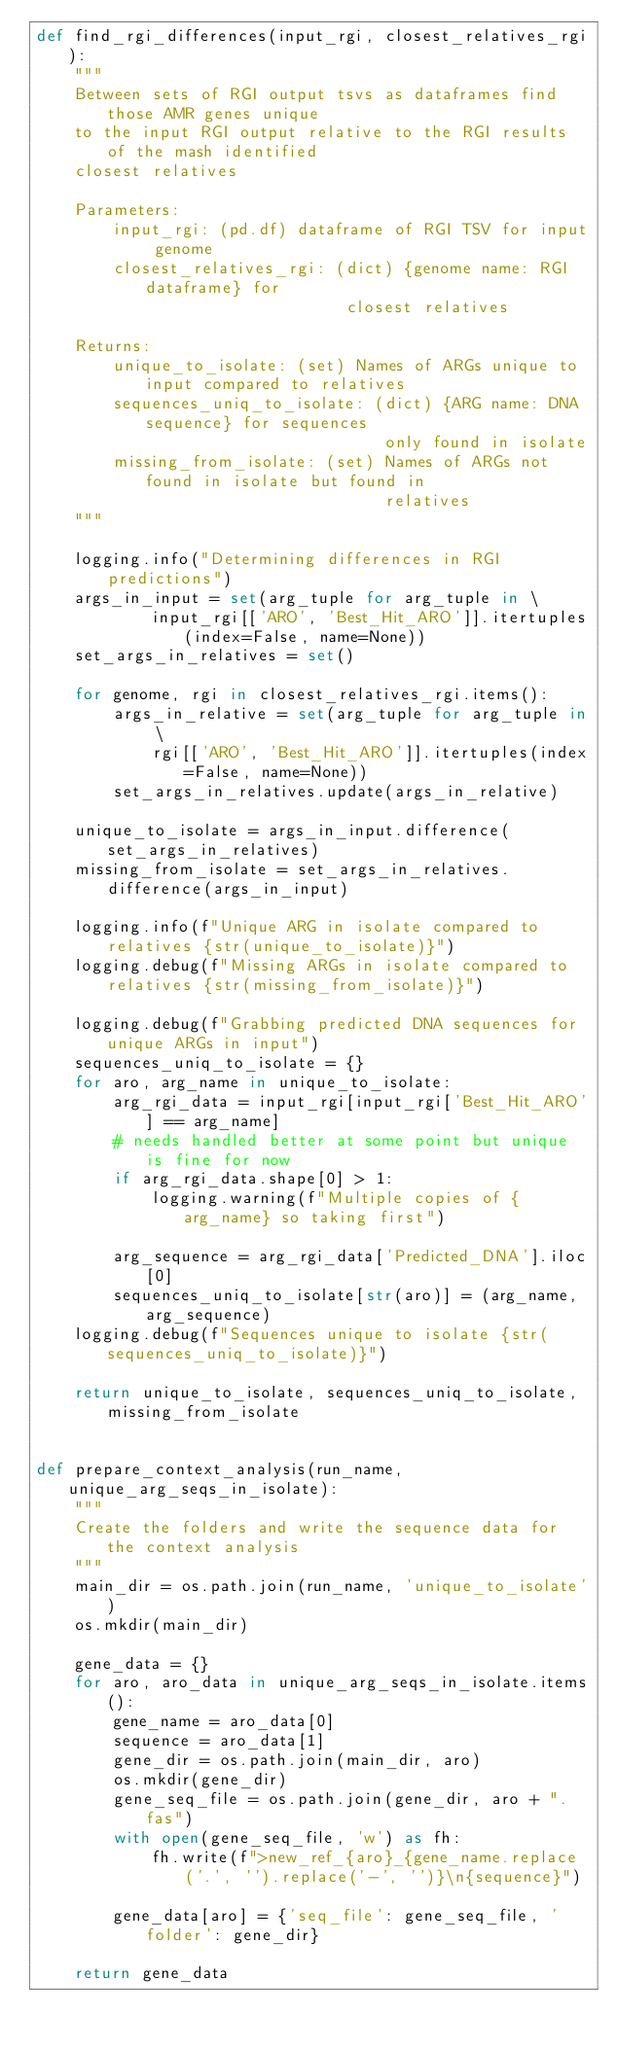Convert code to text. <code><loc_0><loc_0><loc_500><loc_500><_Python_>def find_rgi_differences(input_rgi, closest_relatives_rgi):
    """
    Between sets of RGI output tsvs as dataframes find those AMR genes unique
    to the input RGI output relative to the RGI results of the mash identified
    closest relatives

    Parameters:
        input_rgi: (pd.df) dataframe of RGI TSV for input genome
        closest_relatives_rgi: (dict) {genome name: RGI dataframe} for
                                closest relatives

    Returns:
        unique_to_isolate: (set) Names of ARGs unique to input compared to relatives
        sequences_uniq_to_isolate: (dict) {ARG name: DNA sequence} for sequences
                                    only found in isolate
        missing_from_isolate: (set) Names of ARGs not found in isolate but found in
                                    relatives
    """

    logging.info("Determining differences in RGI predictions")
    args_in_input = set(arg_tuple for arg_tuple in \
            input_rgi[['ARO', 'Best_Hit_ARO']].itertuples(index=False, name=None))
    set_args_in_relatives = set()

    for genome, rgi in closest_relatives_rgi.items():
        args_in_relative = set(arg_tuple for arg_tuple in \
            rgi[['ARO', 'Best_Hit_ARO']].itertuples(index=False, name=None))
        set_args_in_relatives.update(args_in_relative)

    unique_to_isolate = args_in_input.difference(set_args_in_relatives)
    missing_from_isolate = set_args_in_relatives.difference(args_in_input)

    logging.info(f"Unique ARG in isolate compared to relatives {str(unique_to_isolate)}")
    logging.debug(f"Missing ARGs in isolate compared to relatives {str(missing_from_isolate)}")

    logging.debug(f"Grabbing predicted DNA sequences for unique ARGs in input")
    sequences_uniq_to_isolate = {}
    for aro, arg_name in unique_to_isolate:
        arg_rgi_data = input_rgi[input_rgi['Best_Hit_ARO'] == arg_name]
        # needs handled better at some point but unique is fine for now
        if arg_rgi_data.shape[0] > 1:
            logging.warning(f"Multiple copies of {arg_name} so taking first")

        arg_sequence = arg_rgi_data['Predicted_DNA'].iloc[0]
        sequences_uniq_to_isolate[str(aro)] = (arg_name, arg_sequence)
    logging.debug(f"Sequences unique to isolate {str(sequences_uniq_to_isolate)}")

    return unique_to_isolate, sequences_uniq_to_isolate, missing_from_isolate


def prepare_context_analysis(run_name, unique_arg_seqs_in_isolate):
    """
    Create the folders and write the sequence data for the context analysis
    """
    main_dir = os.path.join(run_name, 'unique_to_isolate')
    os.mkdir(main_dir)

    gene_data = {}
    for aro, aro_data in unique_arg_seqs_in_isolate.items():
        gene_name = aro_data[0]
        sequence = aro_data[1]
        gene_dir = os.path.join(main_dir, aro)
        os.mkdir(gene_dir)
        gene_seq_file = os.path.join(gene_dir, aro + ".fas")
        with open(gene_seq_file, 'w') as fh:
            fh.write(f">new_ref_{aro}_{gene_name.replace('.', '').replace('-', '')}\n{sequence}")

        gene_data[aro] = {'seq_file': gene_seq_file, 'folder': gene_dir}

    return gene_data

</code> 